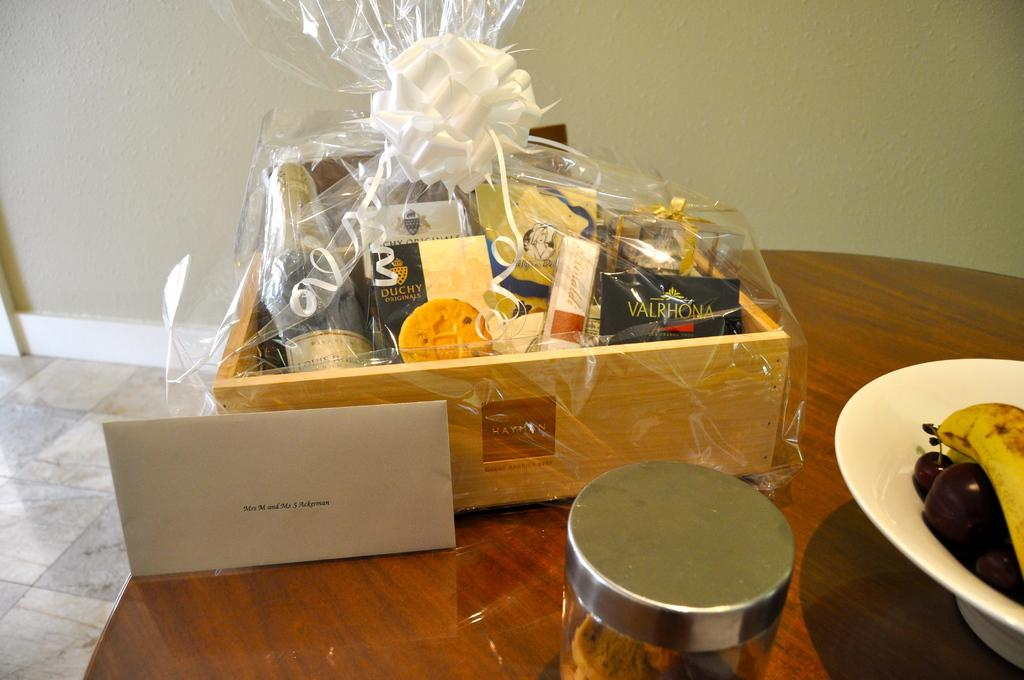What is the main object in the center of the image? There is a box in the center of the image. What is located on the right side of the image? There is a bowl of fruits on the right side of the image. Where are the box and the bowl of fruits placed? Both the box and the bowl of fruits are placed on a table. Reasoning: Let' Let's think step by step in order to produce the conversation. We start by identifying the main objects in the image, which are the box and the bowl of fruits. Then, we describe their locations and the surface they are placed on, which is a table. Each question is designed to elicit a specific detail about the image that is known from the provided facts. Absurd Question/Answer: What type of skin can be seen on the box in the image? There is no skin present on the box in the image. What type of leather is used to make the bowl of fruits in the image? The bowl of fruits is not made of leather, and there is no leather present in the image. 